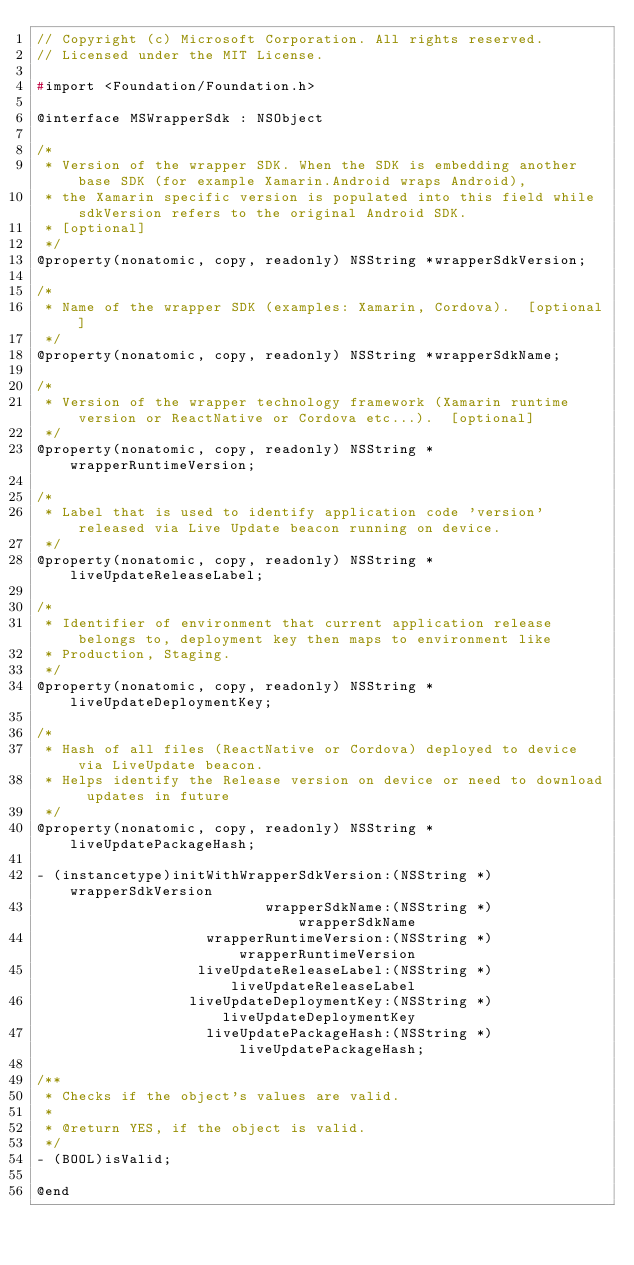<code> <loc_0><loc_0><loc_500><loc_500><_C_>// Copyright (c) Microsoft Corporation. All rights reserved.
// Licensed under the MIT License.

#import <Foundation/Foundation.h>

@interface MSWrapperSdk : NSObject

/*
 * Version of the wrapper SDK. When the SDK is embedding another base SDK (for example Xamarin.Android wraps Android),
 * the Xamarin specific version is populated into this field while sdkVersion refers to the original Android SDK.
 * [optional]
 */
@property(nonatomic, copy, readonly) NSString *wrapperSdkVersion;

/*
 * Name of the wrapper SDK (examples: Xamarin, Cordova).  [optional]
 */
@property(nonatomic, copy, readonly) NSString *wrapperSdkName;

/*
 * Version of the wrapper technology framework (Xamarin runtime version or ReactNative or Cordova etc...).  [optional]
 */
@property(nonatomic, copy, readonly) NSString *wrapperRuntimeVersion;

/*
 * Label that is used to identify application code 'version' released via Live Update beacon running on device.
 */
@property(nonatomic, copy, readonly) NSString *liveUpdateReleaseLabel;

/*
 * Identifier of environment that current application release belongs to, deployment key then maps to environment like
 * Production, Staging.
 */
@property(nonatomic, copy, readonly) NSString *liveUpdateDeploymentKey;

/*
 * Hash of all files (ReactNative or Cordova) deployed to device via LiveUpdate beacon.
 * Helps identify the Release version on device or need to download updates in future
 */
@property(nonatomic, copy, readonly) NSString *liveUpdatePackageHash;

- (instancetype)initWithWrapperSdkVersion:(NSString *)wrapperSdkVersion
                           wrapperSdkName:(NSString *)wrapperSdkName
                    wrapperRuntimeVersion:(NSString *)wrapperRuntimeVersion
                   liveUpdateReleaseLabel:(NSString *)liveUpdateReleaseLabel
                  liveUpdateDeploymentKey:(NSString *)liveUpdateDeploymentKey
                    liveUpdatePackageHash:(NSString *)liveUpdatePackageHash;

/**
 * Checks if the object's values are valid.
 *
 * @return YES, if the object is valid.
 */
- (BOOL)isValid;

@end
</code> 